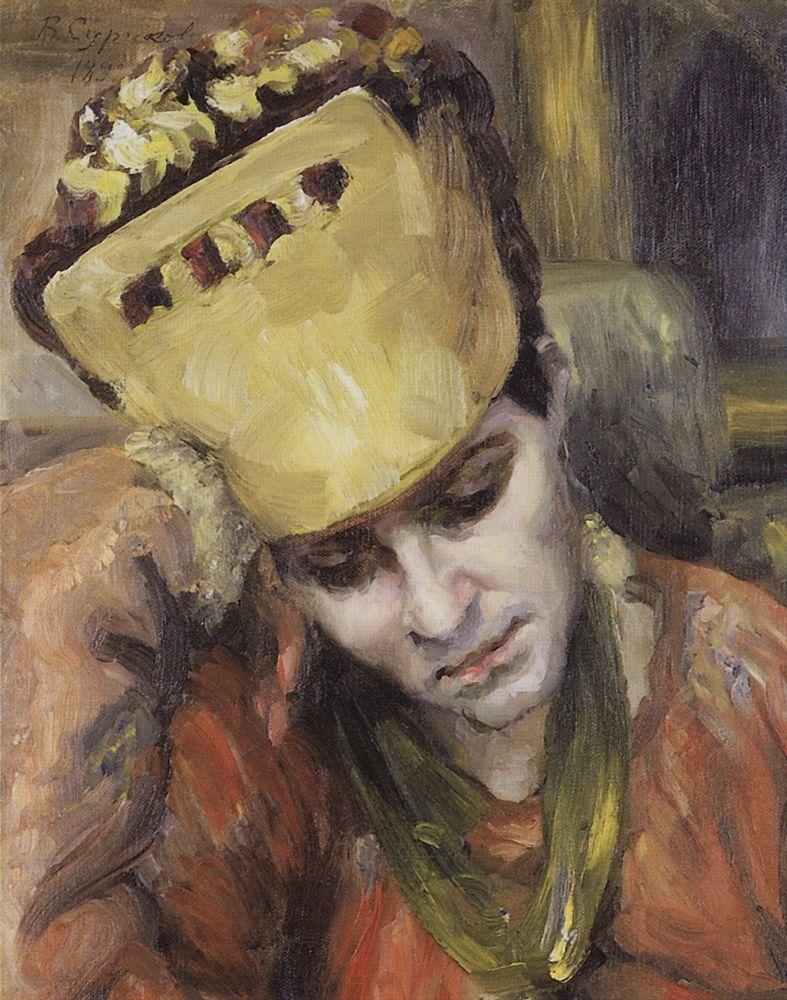Can you provide another short, realistic scenario inspired by this painting? Lina, the woman in the painting, often sits in her modest kitchen with a cup of tea, reflecting on her day. The yellow hat, a rare indulgence, adds a touch of brightness to her otherwise routine life. She ponders her future, dreaming of adventures beyond her small village, but for now, she remains grounded in the simplicity of her everyday existence. 